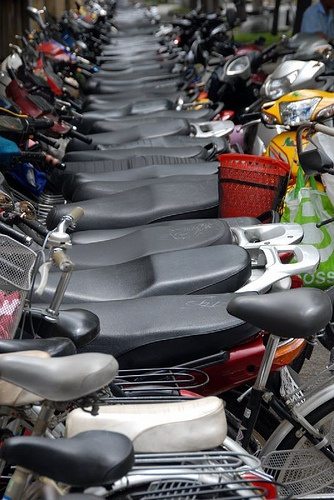Describe the objects in this image and their specific colors. I can see motorcycle in black, gray, darkgray, and lightgray tones, bicycle in black, gray, darkgray, and lightgray tones, motorcycle in black and gray tones, motorcycle in black, gray, darkgray, and white tones, and bicycle in black, gray, darkgray, and lightgray tones in this image. 